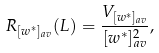Convert formula to latex. <formula><loc_0><loc_0><loc_500><loc_500>R _ { [ w ^ { \ast } ] _ { a v } } ( L ) = \frac { V _ { [ w ^ { \ast } ] _ { a v } } } { [ w ^ { \ast } ] _ { a v } ^ { 2 } } ,</formula> 